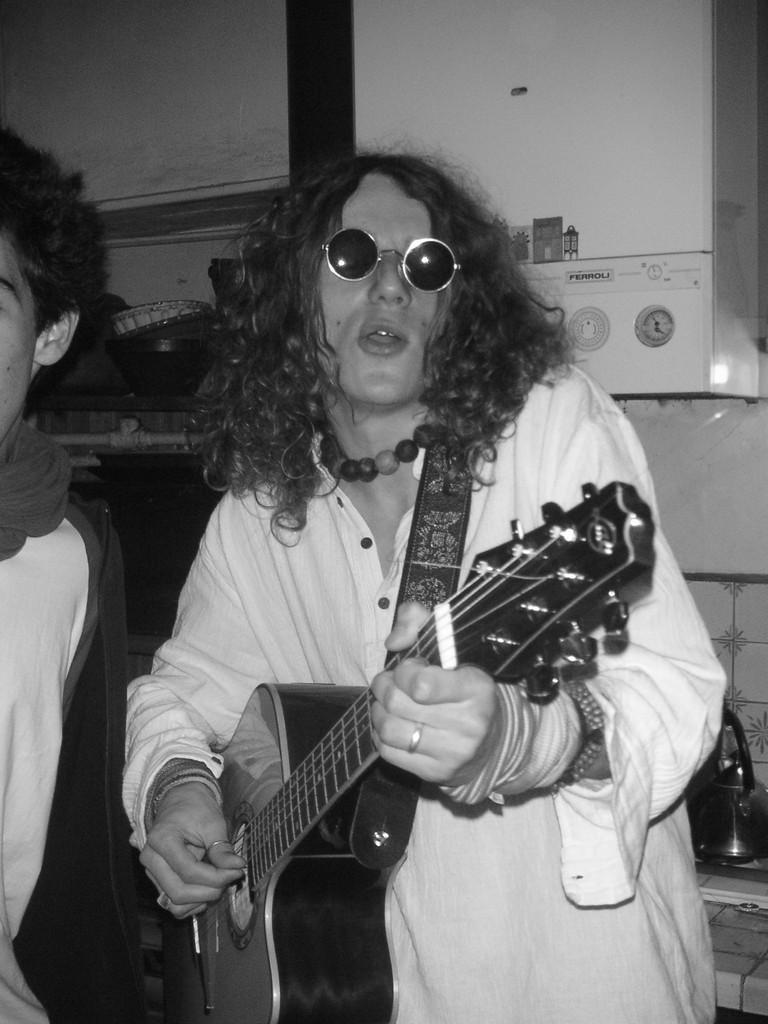How would you summarize this image in a sentence or two? In this image there is a person wearing white color dress playing guitar. 